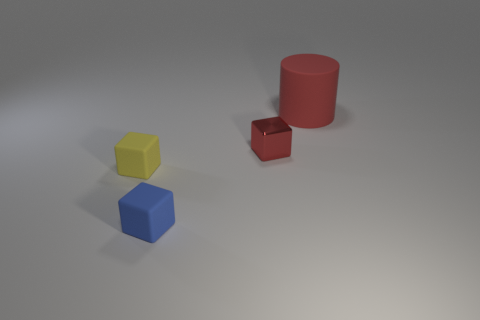What is the color of the big matte cylinder?
Make the answer very short. Red. There is a red thing in front of the red cylinder; is it the same shape as the tiny blue object?
Offer a terse response. Yes. What is the material of the small red cube?
Offer a very short reply. Metal. There is a blue rubber thing that is the same size as the red block; what is its shape?
Ensure brevity in your answer.  Cube. Is there a small shiny object of the same color as the big matte thing?
Provide a succinct answer. Yes. There is a big thing; is it the same color as the thing that is on the left side of the small blue thing?
Offer a terse response. No. There is a matte thing that is in front of the yellow cube that is to the left of the shiny block; what is its color?
Give a very brief answer. Blue. There is a tiny block that is left of the tiny cube that is in front of the yellow rubber block; is there a blue rubber thing on the left side of it?
Make the answer very short. No. The block that is the same material as the blue thing is what color?
Offer a very short reply. Yellow. How many other objects are the same material as the tiny yellow thing?
Keep it short and to the point. 2. 